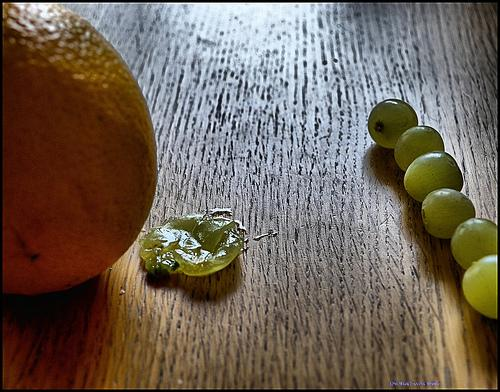Count the total number of objects on the table, including fruits and their shadows. There are 12 objects on the table: 1 unpeeled orange, 1 shadow of the whole orange, 6 green grapes, 1 smashed grape, 1 squished grape juice, 1 shadow of squished grape, and 1 shadow of lined up grapes. Discuss the possible interaction between the whole orange and the lined up green grapes on the table. The whole orange serves as a contrasting focal point amongst the smaller green grapes that are lined up, creating an interesting visual arrangement on the table. Describe the influence of light in the image. The light creates a glare and shadow on the table, a light reflection on the orange, and sunlight from the source of light. Using complex reasoning, can you infer what might have happened to the smashed grape? The smashed grape may have been accidentally crushed or intentionally squashed, resulting in its juice spilling on the table. Mention the visible defects of the orange on the table. There is a small bruise, a dent, and some dirt on the side of the orange. What is the condition of the green grape next to the smashed grape on the table? The green grape next to the smashed grape appears shiny and unbroken. Assess the quality of the wooden table's surface in the image. The wooden table's surface has visible grains, black lines, and a shiny area caused by the light reflection, giving it character and a rustic appearance. Determine the sentiment conveyed by the image of the table with fruit. The sentiment of the image is fresh, vibrant, and inviting due to the presence of fruits on the wooden table. How many green grapes are lined up on the table? There are six green grapes lined up on the table. List the types of fruits seen on the wooden table. Grapes and a whole unpeeled orange are on the wooden table. Describe the shadows in the image. Shadows of smushed grape, lined up grapes, and whole orange. What kind of table is the fruit sitting on? A wooden table with visible grain and black lines. What does the table fruit consists of? Green grapes, smashed grape, and an unpeeled orange. Which fruit on the table has a bruise? The unpeeled orange has a small bruise. What's glaring on the table's surface? Light shining off of the table. Is there any similarity between the green grapes and the smushed grape? Yes, both are grapes. What is the color of the grapes on the table? Green How many objects on the table? Six green grapes, a smashed grape, and an unpeeled orange. What is the light source and its effect on the objects? Sunlight; causing glare on the table and shining off some objects. Describe the state of a grape near the orange. A smashed grape and its juice are near the orange. Select the odd one out: green grape, smushed grape, unpeeled orange, wooden table. Wooden table Which objects display the effect of sunlight? The table, grapes, and orange. Are there any smashed grapes on the table? Yes, there is a smashed grape with shadow and juice. Describe the table's surface. The table has wooden surface with black lines and visible grains. Is there an orange in the image, and if so, what is its main feature?  Yes, there is an unpeeled orange with a small bruise. What type of fruit is on the table? Grapes and an orange. What is the dominant object in the image? A wooden table with fruit on it Where are the green grapes positioned on the table? The green grapes are lined up on the table. Finish the line with referring object: There is something ________ on the table? Wet and squished from a grape. 